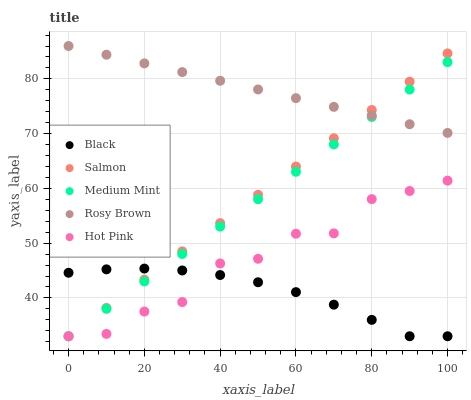Does Black have the minimum area under the curve?
Answer yes or no. Yes. Does Rosy Brown have the maximum area under the curve?
Answer yes or no. Yes. Does Salmon have the minimum area under the curve?
Answer yes or no. No. Does Salmon have the maximum area under the curve?
Answer yes or no. No. Is Medium Mint the smoothest?
Answer yes or no. Yes. Is Hot Pink the roughest?
Answer yes or no. Yes. Is Salmon the smoothest?
Answer yes or no. No. Is Salmon the roughest?
Answer yes or no. No. Does Medium Mint have the lowest value?
Answer yes or no. Yes. Does Rosy Brown have the lowest value?
Answer yes or no. No. Does Rosy Brown have the highest value?
Answer yes or no. Yes. Does Salmon have the highest value?
Answer yes or no. No. Is Hot Pink less than Rosy Brown?
Answer yes or no. Yes. Is Rosy Brown greater than Hot Pink?
Answer yes or no. Yes. Does Rosy Brown intersect Medium Mint?
Answer yes or no. Yes. Is Rosy Brown less than Medium Mint?
Answer yes or no. No. Is Rosy Brown greater than Medium Mint?
Answer yes or no. No. Does Hot Pink intersect Rosy Brown?
Answer yes or no. No. 